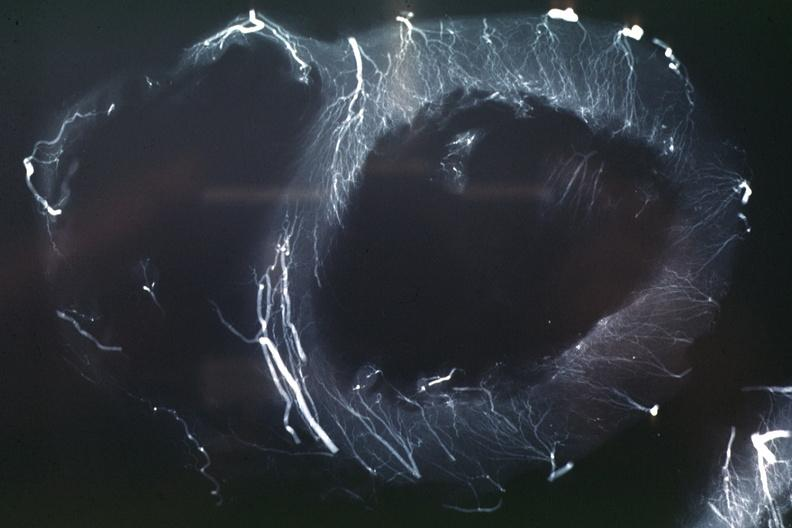what is present?
Answer the question using a single word or phrase. Angiogram 